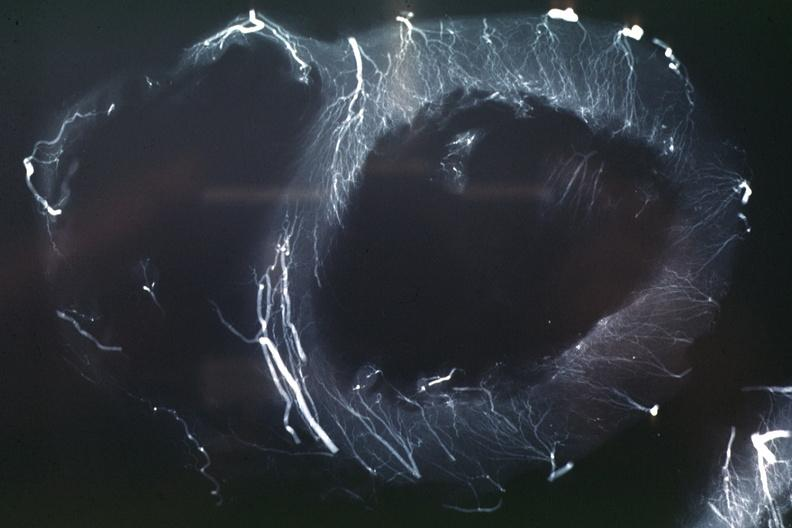what is present?
Answer the question using a single word or phrase. Angiogram 